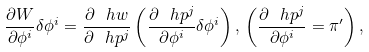<formula> <loc_0><loc_0><loc_500><loc_500>\frac { \partial W } { \partial \phi ^ { i } } \delta \phi ^ { i } = \frac { \partial \ h w } { \partial \ h p ^ { j } } \left ( \frac { \partial \ h p ^ { j } } { \partial \phi ^ { i } } \delta \phi ^ { i } \right ) , \, \left ( \frac { \partial \ h p ^ { j } } { \partial \phi ^ { i } } = \pi ^ { \prime } \right ) ,</formula> 